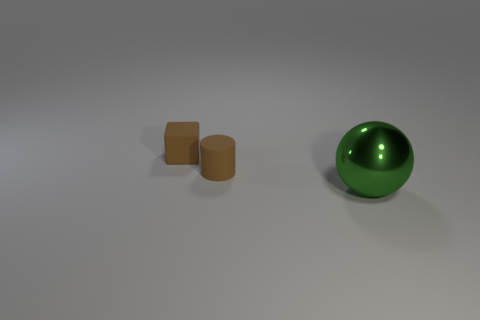Does the matte thing on the right side of the block have the same color as the small thing that is to the left of the brown rubber cylinder?
Your response must be concise. Yes. What shape is the brown rubber thing that is the same size as the matte block?
Keep it short and to the point. Cylinder. Are there any other big metal objects of the same shape as the big metallic object?
Your answer should be very brief. No. What is the large sphere made of?
Give a very brief answer. Metal. Are there any tiny things behind the large green ball?
Keep it short and to the point. Yes. How many brown matte blocks are behind the rubber thing that is right of the small brown matte block?
Make the answer very short. 1. What number of other things are the same material as the brown cylinder?
Ensure brevity in your answer.  1. How many objects are right of the big metallic object?
Offer a very short reply. 0. What number of balls are big purple metallic things or green things?
Your answer should be very brief. 1. How many other objects are there of the same color as the large metallic ball?
Provide a short and direct response. 0. 